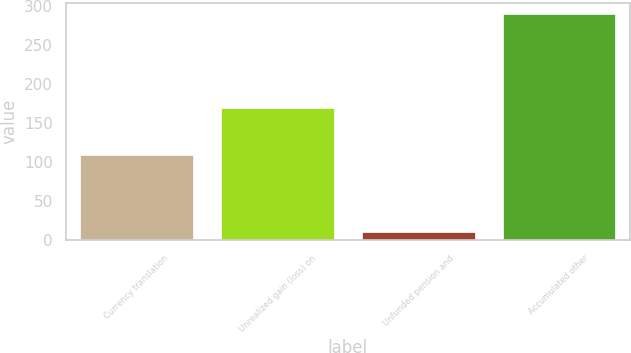Convert chart. <chart><loc_0><loc_0><loc_500><loc_500><bar_chart><fcel>Currency translation<fcel>Unrealized gain (loss) on<fcel>Unfunded pension and<fcel>Accumulated other<nl><fcel>109<fcel>170<fcel>11<fcel>290<nl></chart> 